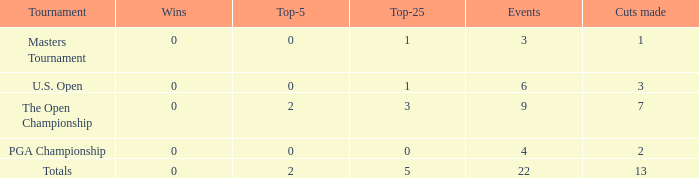What is the fewest number of top-25s for events with more than 13 cuts made? None. 